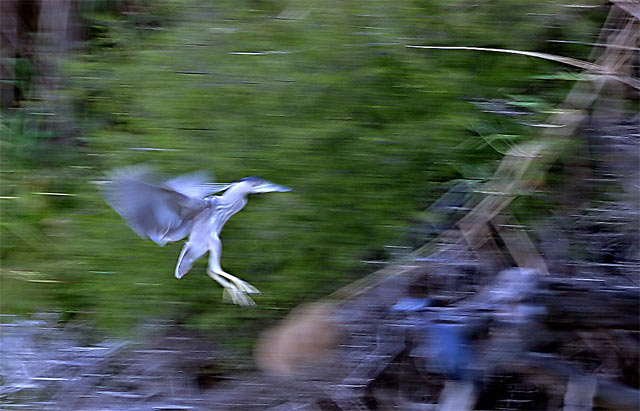What time of day do you think this photo was taken? Given the soft, diffused lighting and lack of harsh shadows, it seems plausible that the photo was taken either in the early morning or late afternoon, during what photographers refer to as the 'golden hour,' when the light is warmer and softer. 